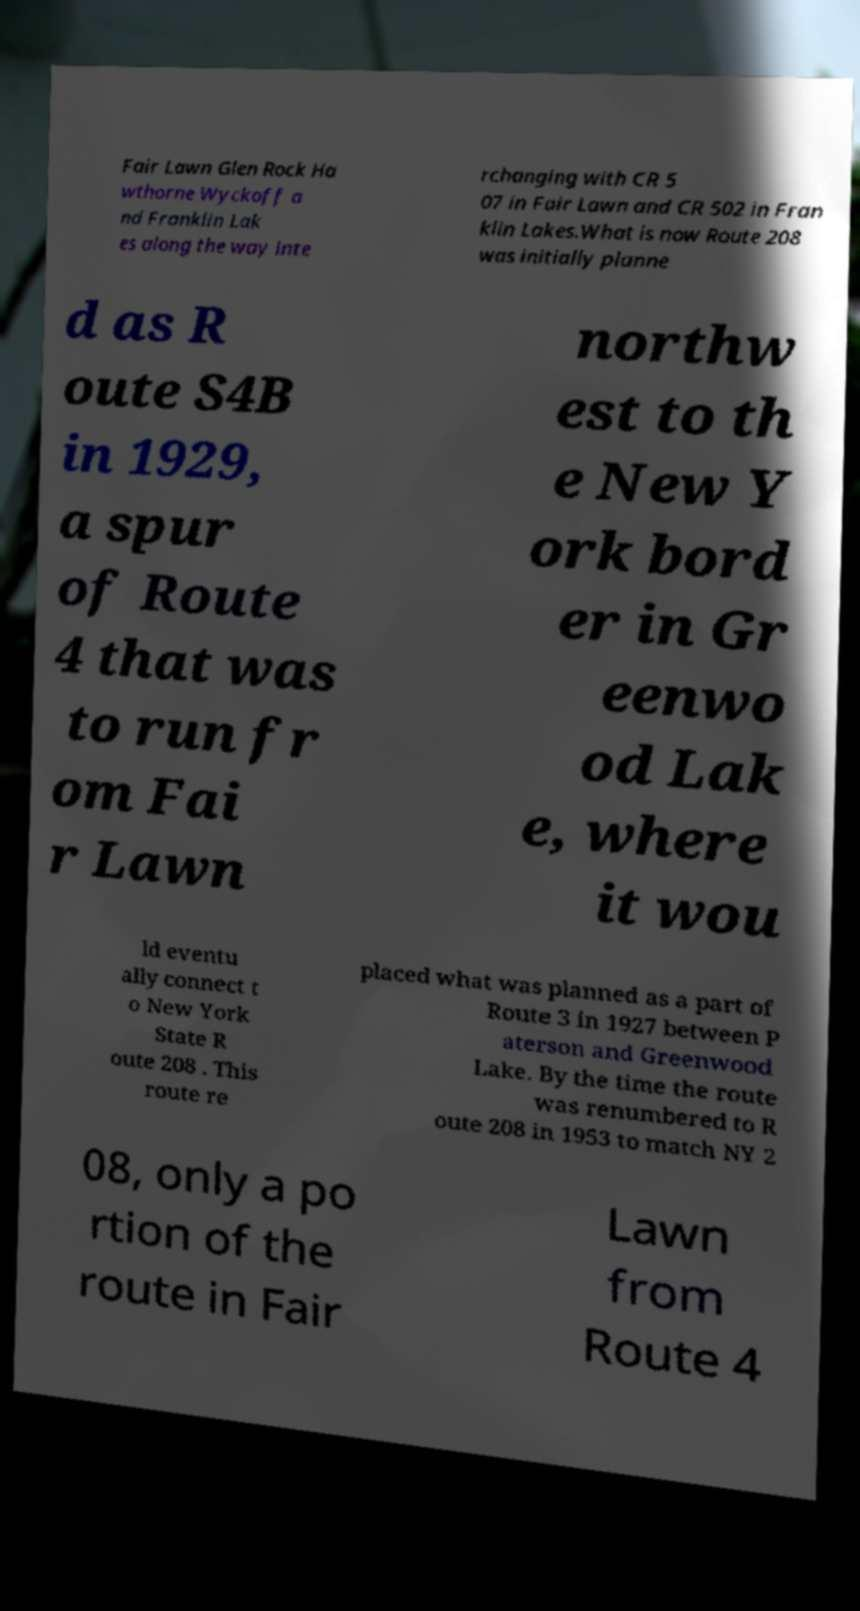I need the written content from this picture converted into text. Can you do that? Fair Lawn Glen Rock Ha wthorne Wyckoff a nd Franklin Lak es along the way inte rchanging with CR 5 07 in Fair Lawn and CR 502 in Fran klin Lakes.What is now Route 208 was initially planne d as R oute S4B in 1929, a spur of Route 4 that was to run fr om Fai r Lawn northw est to th e New Y ork bord er in Gr eenwo od Lak e, where it wou ld eventu ally connect t o New York State R oute 208 . This route re placed what was planned as a part of Route 3 in 1927 between P aterson and Greenwood Lake. By the time the route was renumbered to R oute 208 in 1953 to match NY 2 08, only a po rtion of the route in Fair Lawn from Route 4 